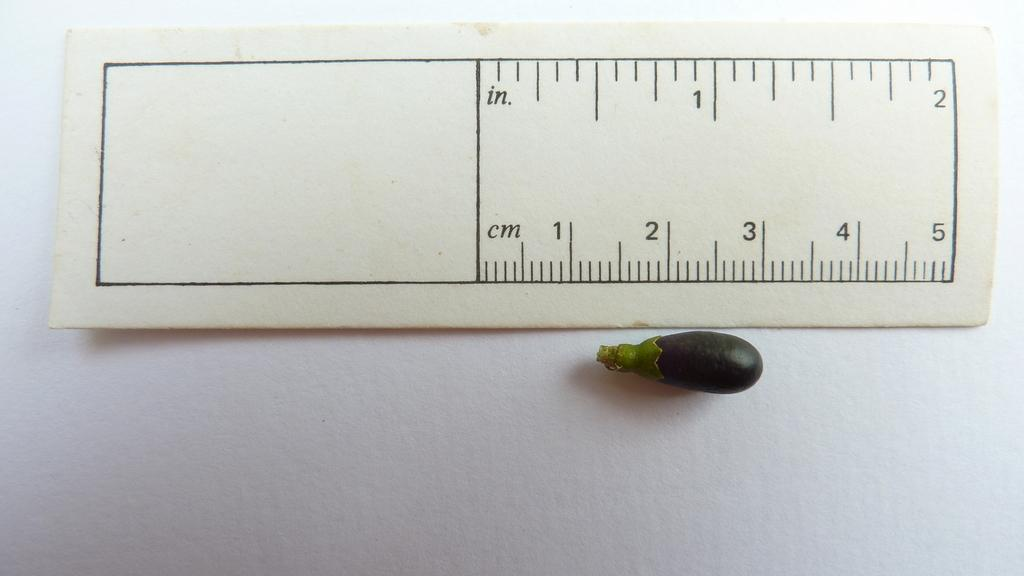Provide a one-sentence caption for the provided image. A measurement of a small eggplant, showing it as under 2 cm. 